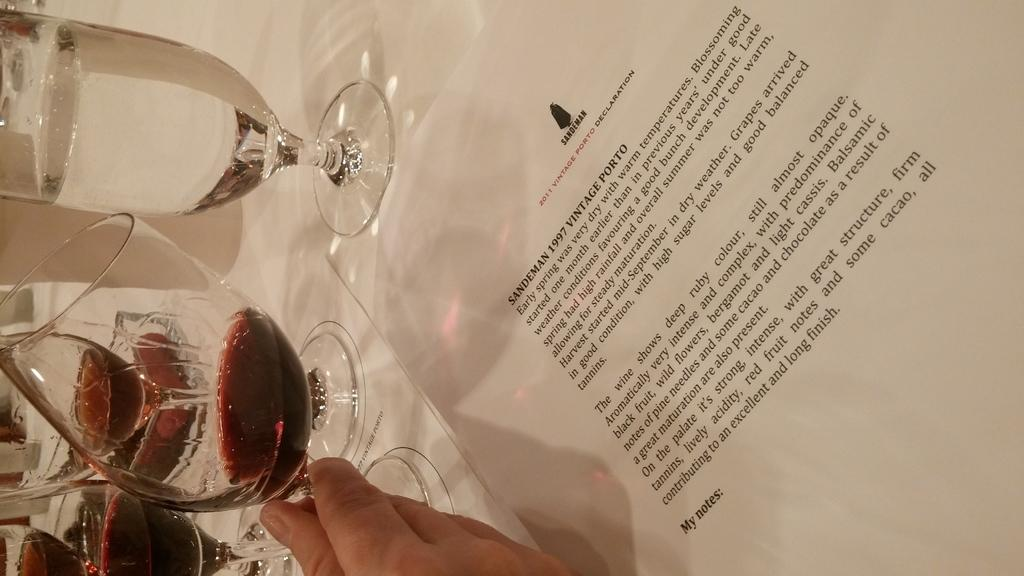What objects in the image contain liquid? There are glasses with liquid in the image. What is on the table in the image? There is a paper on a table in the image. Can you describe any body parts visible in the image? A hand of a person is visible at the bottom of the image, but it is truncated. What type of baseball is being played in the image? There is no baseball or any indication of a baseball game in the image. 